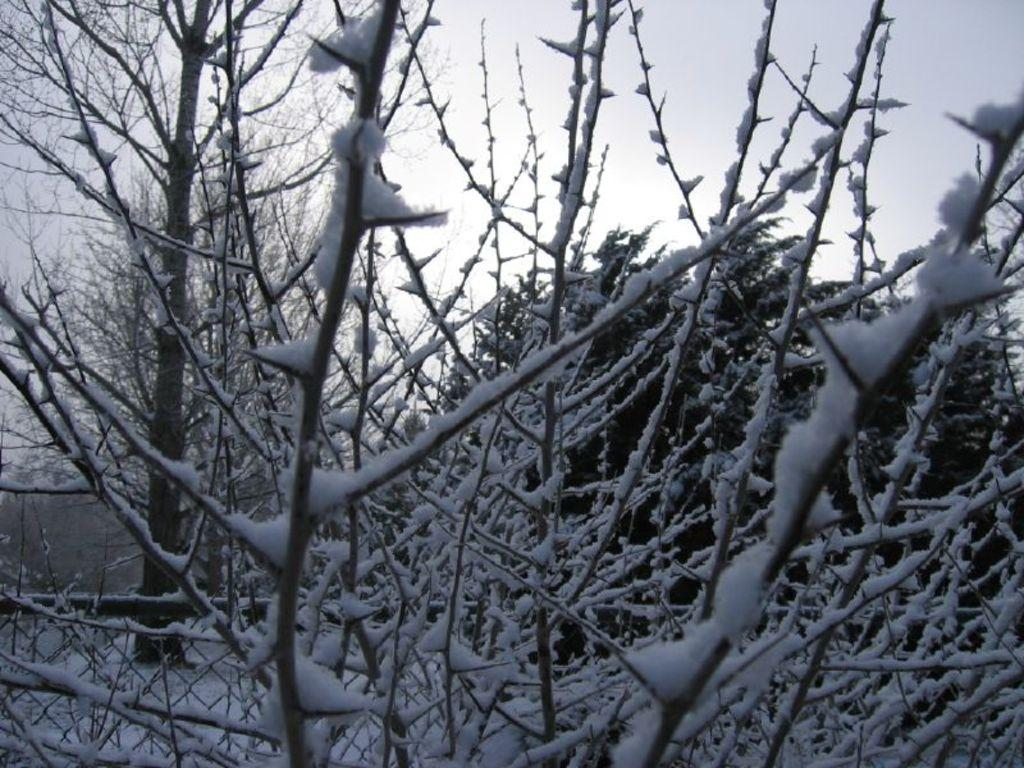What type of vegetation can be seen in the image? There are trees in the image. What is covering the trees in the image? There is snow on the trees. What is visible at the top of the image? The sky is visible at the top of the image. What type of weather is suggested by the presence of snow in the image? The presence of snow suggests cold weather. What type of joke can be seen on the gravestone in the image? There is no gravestone or joke present in the image; it features trees with snow. What type of knife is being used to cut the snow in the image? There is no knife present in the image; it only shows trees with snow and the sky. 